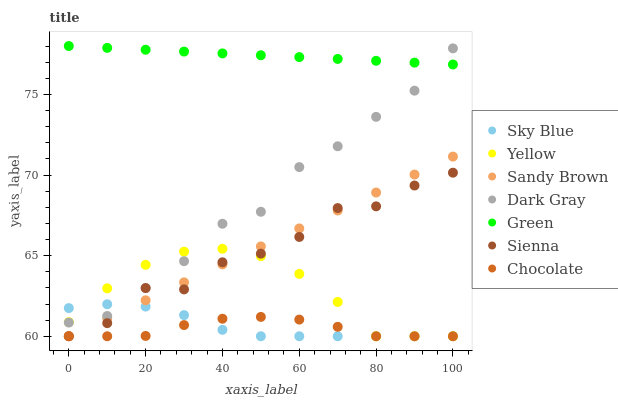Does Chocolate have the minimum area under the curve?
Answer yes or no. Yes. Does Green have the maximum area under the curve?
Answer yes or no. Yes. Does Yellow have the minimum area under the curve?
Answer yes or no. No. Does Yellow have the maximum area under the curve?
Answer yes or no. No. Is Sandy Brown the smoothest?
Answer yes or no. Yes. Is Sienna the roughest?
Answer yes or no. Yes. Is Yellow the smoothest?
Answer yes or no. No. Is Yellow the roughest?
Answer yes or no. No. Does Yellow have the lowest value?
Answer yes or no. Yes. Does Dark Gray have the lowest value?
Answer yes or no. No. Does Green have the highest value?
Answer yes or no. Yes. Does Yellow have the highest value?
Answer yes or no. No. Is Sienna less than Dark Gray?
Answer yes or no. Yes. Is Dark Gray greater than Chocolate?
Answer yes or no. Yes. Does Sandy Brown intersect Chocolate?
Answer yes or no. Yes. Is Sandy Brown less than Chocolate?
Answer yes or no. No. Is Sandy Brown greater than Chocolate?
Answer yes or no. No. Does Sienna intersect Dark Gray?
Answer yes or no. No. 